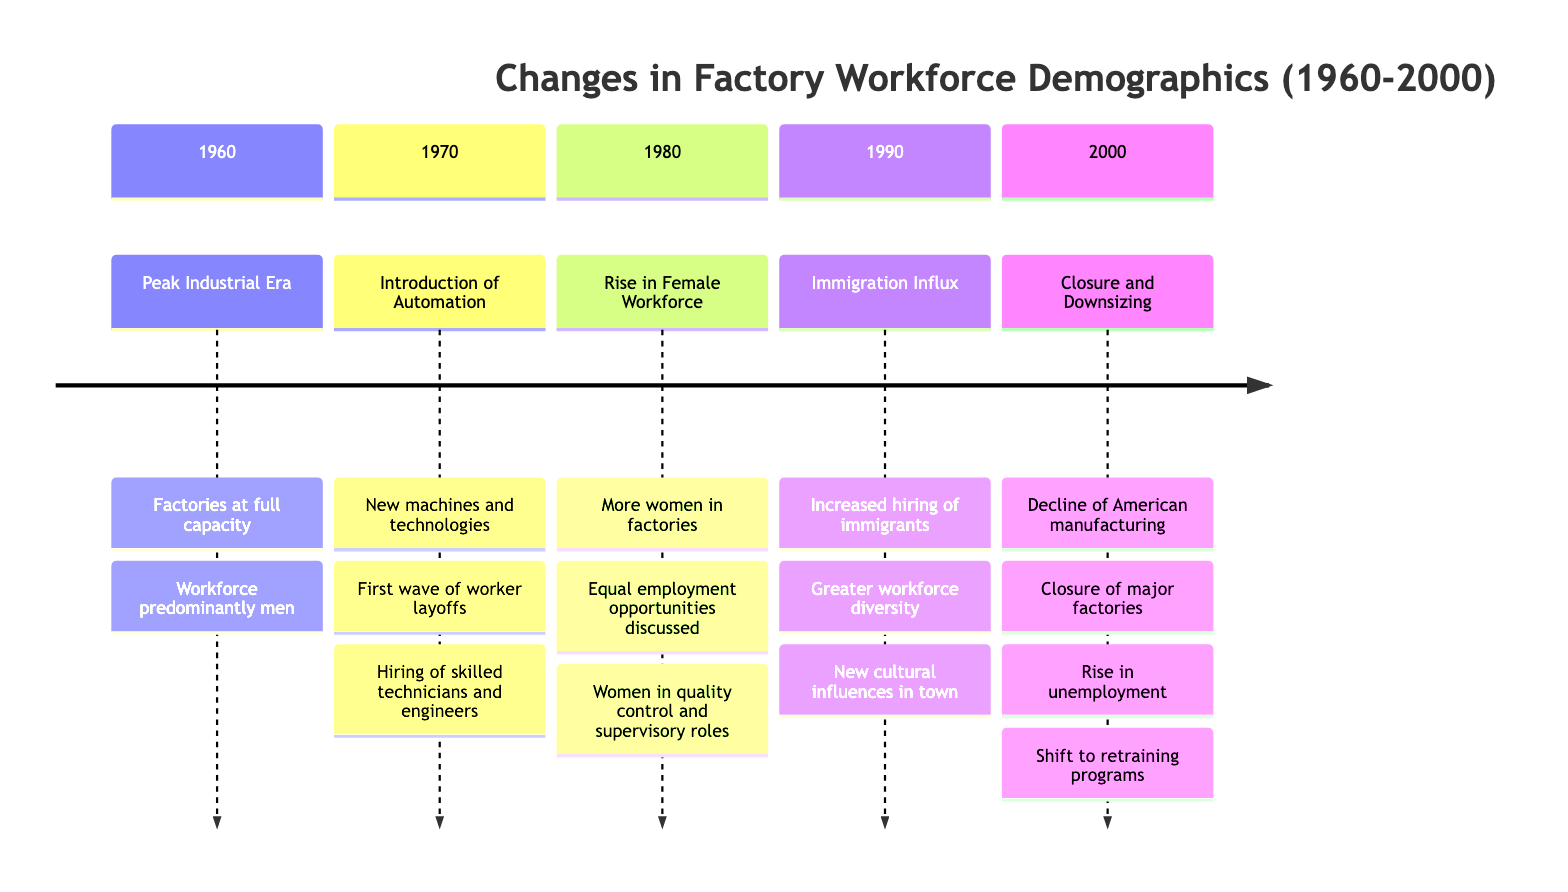What year did the Peak Industrial Era occur? The diagram specifies that the Peak Industrial Era occurred in 1960. Therefore, looking at the timeline, this is the year marked for this event.
Answer: 1960 How did the workforce demographic change in 1970? The timeline indicates that in 1970, automation led to layoffs and the hiring of skilled technicians and engineers, changing the demographic. This implies a significant shift in the types of workers present.
Answer: Hiring of skilled technicians and engineers What significant event happened in 1980? According to the diagram, the rise in the female workforce in 1980 marked a significant change, as more women began taking roles traditionally occupied by men, particularly in quality control and supervisory positions.
Answer: Rise in Female Workforce What was the primary reason for the Immigration Influx in 1990? The diagram highlights that the local factories increased hiring immigrants due to labor shortages and economic upheavals in other regions, indicating the primary reason behind this demographic change.
Answer: Labor shortages How did the Closure and Downsizing in 2000 impact the local community? The timeline states that the closure of major factories resulted in a significant rise in unemployment, highlighting the economic challenges faced by the local community during that period.
Answer: Rise in unemployment What overarching trend is observed from 1960 to 2000? The timeline reveals an overarching trend of decline in manufacturing, marked by the shift from a predominantly male workforce in 1960 to an increased diversity in 1990 and eventual factory closures by 2000. This indicates a broader shift in the local economy.
Answer: Decline of American manufacturing In which year did discussions about equal employment opportunities start? The timeline indicates that discussions about equal employment opportunities began around 1980, coinciding with the rise of women in the workforce and their movement into roles previously held by men.
Answer: 1980 What was a cultural impact noted in 1990? The addition of an increasing number of immigrants added cultural diversity to the workforce and the town, highlighting new cultural influences and creating support centers for newcomers.
Answer: Greater workforce diversity What major factor contributed to the first wave of layoffs in 1970? The introduction of automation and new production technologies in the year 1970 is identified as the major factor that led to the first wave of layoffs in the local factories.
Answer: Automation 